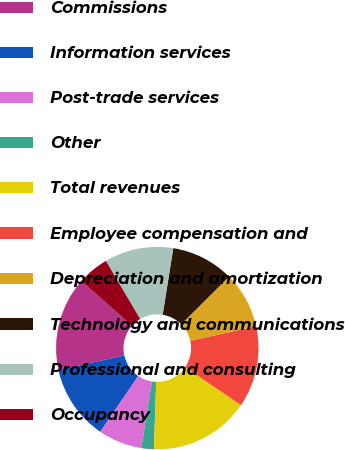Convert chart. <chart><loc_0><loc_0><loc_500><loc_500><pie_chart><fcel>Commissions<fcel>Information services<fcel>Post-trade services<fcel>Other<fcel>Total revenues<fcel>Employee compensation and<fcel>Depreciation and amortization<fcel>Technology and communications<fcel>Professional and consulting<fcel>Occupancy<nl><fcel>15.0%<fcel>12.0%<fcel>7.0%<fcel>2.0%<fcel>16.0%<fcel>13.0%<fcel>9.0%<fcel>10.0%<fcel>11.0%<fcel>5.0%<nl></chart> 